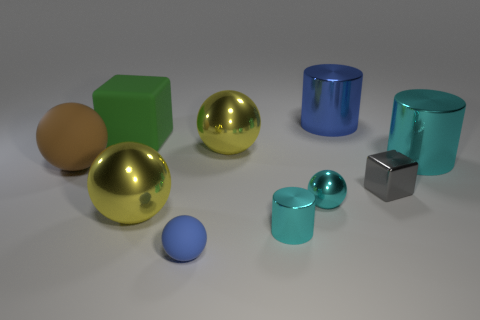Is the large cyan metal object the same shape as the blue rubber thing?
Offer a very short reply. No. Does the cyan cylinder behind the large brown rubber sphere have the same material as the ball that is on the left side of the green rubber block?
Provide a succinct answer. No. What number of things are big yellow objects behind the brown object or tiny metallic objects that are behind the small cyan cylinder?
Offer a very short reply. 3. Is there anything else that is the same shape as the small rubber object?
Offer a very short reply. Yes. What number of small shiny things are there?
Keep it short and to the point. 3. Are there any yellow matte spheres of the same size as the blue matte thing?
Provide a short and direct response. No. Is the blue cylinder made of the same material as the cylinder on the left side of the blue cylinder?
Offer a terse response. Yes. What is the material of the large ball that is right of the tiny blue object?
Ensure brevity in your answer.  Metal. How big is the gray block?
Offer a very short reply. Small. There is a cyan cylinder that is right of the tiny cylinder; does it have the same size as the gray metal object on the right side of the big green block?
Provide a succinct answer. No. 